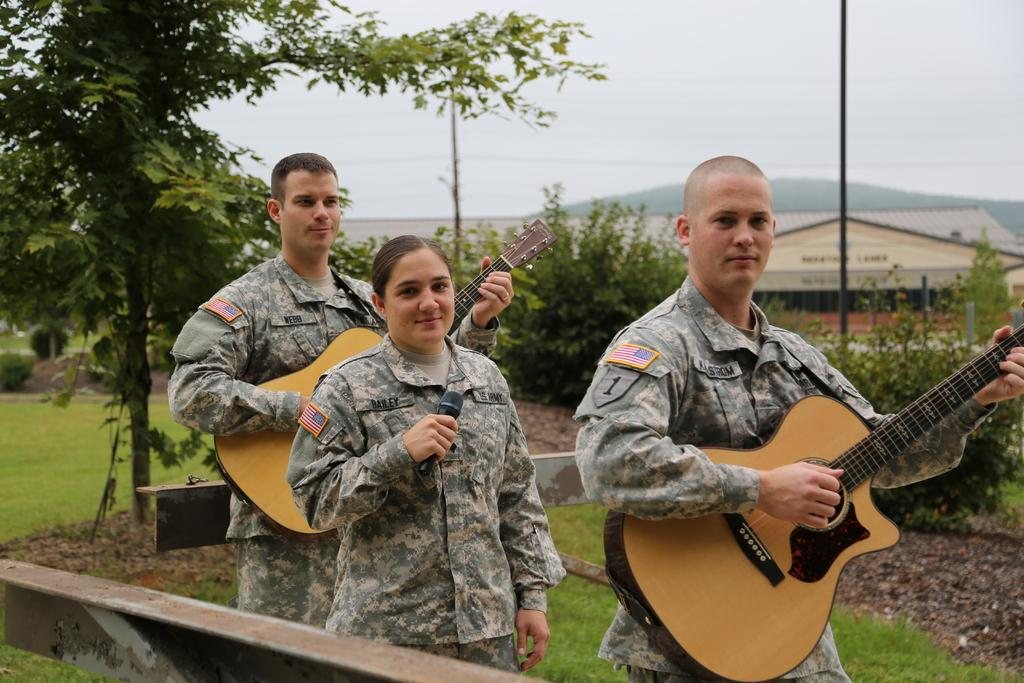Who is the main subject in the image? There is a woman in the image. What is the woman holding in the image? The woman is holding a microphone. How many men are present in the image? There are two men in the image. What are the men holding in the image? The men are holding guitars. What can be seen in the background of the image? There is a tree, the sky, a pole, and a building visible in the background of the image. What is the price of the smoke coming out of the building in the image? There is no smoke coming out of the building in the image, and therefore no price can be determined. 